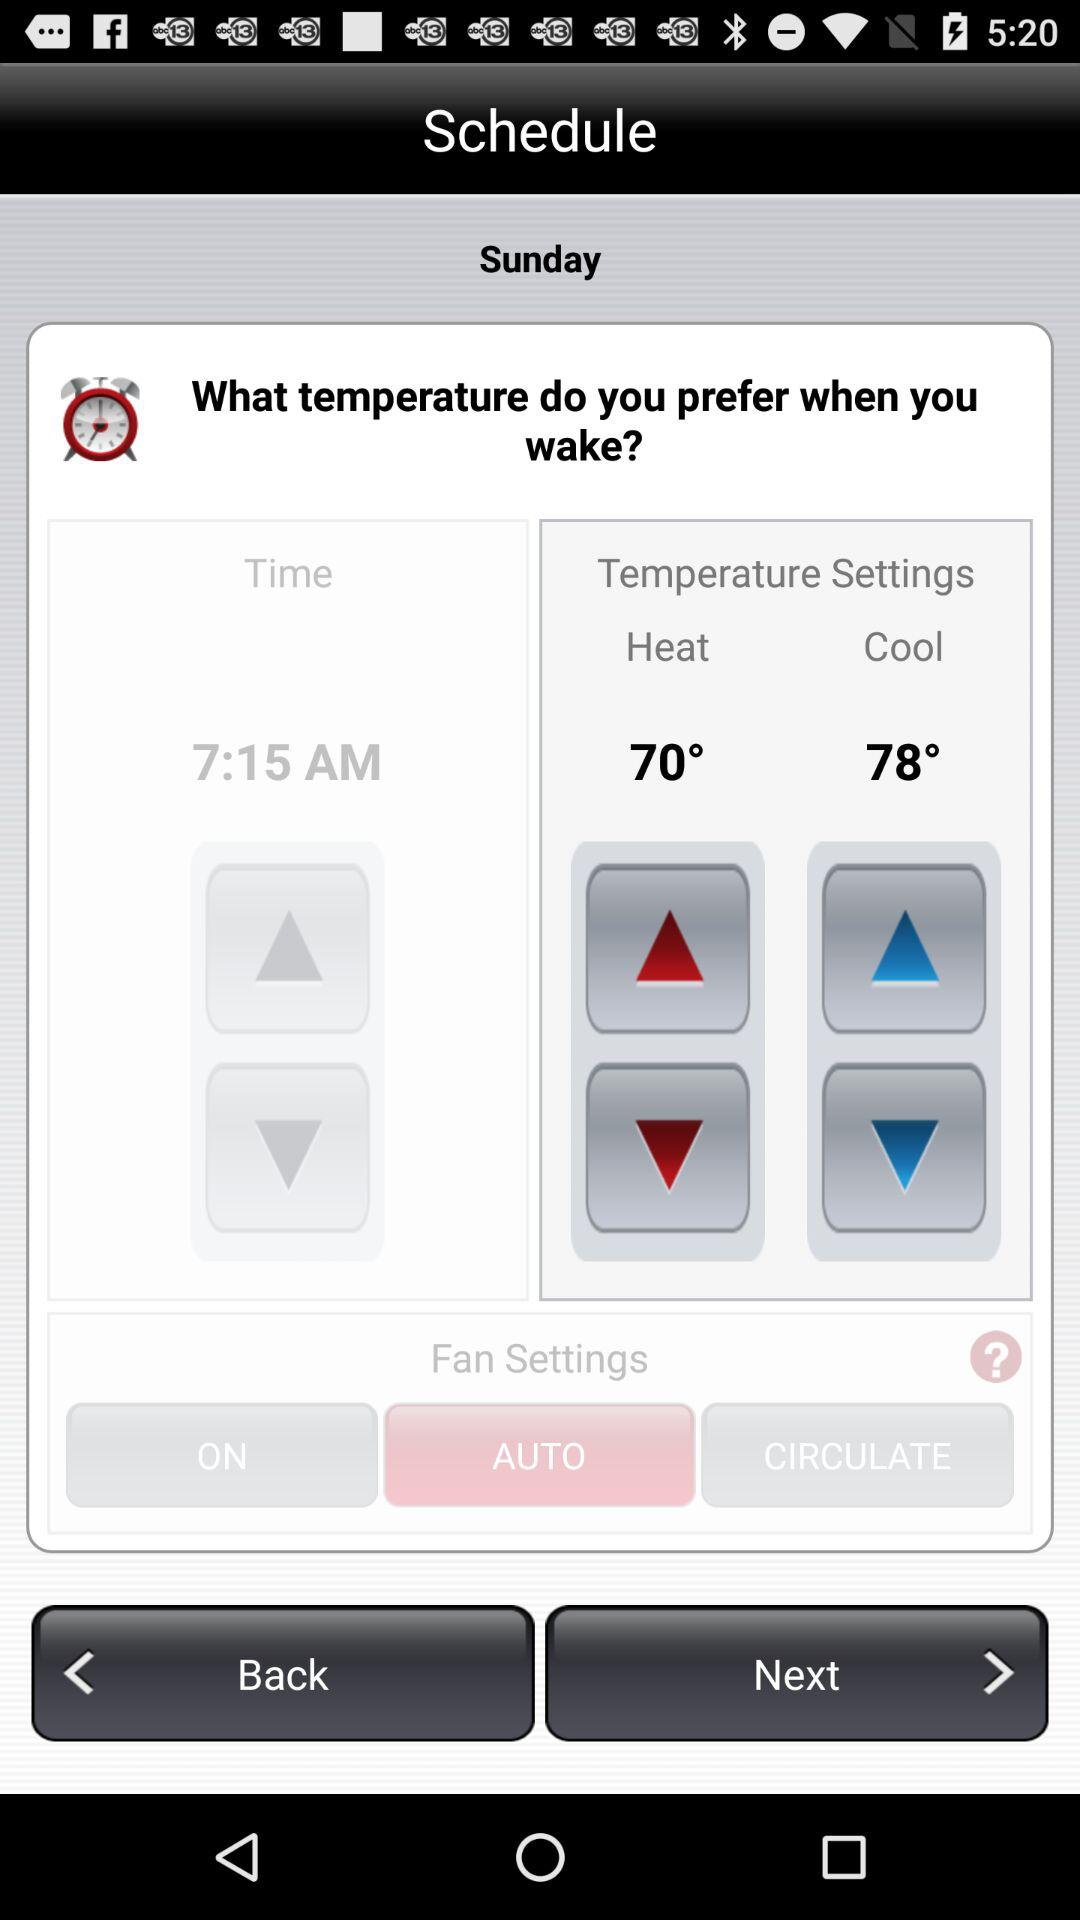What is the temperature of heat? The temperature of heat is 70°. 